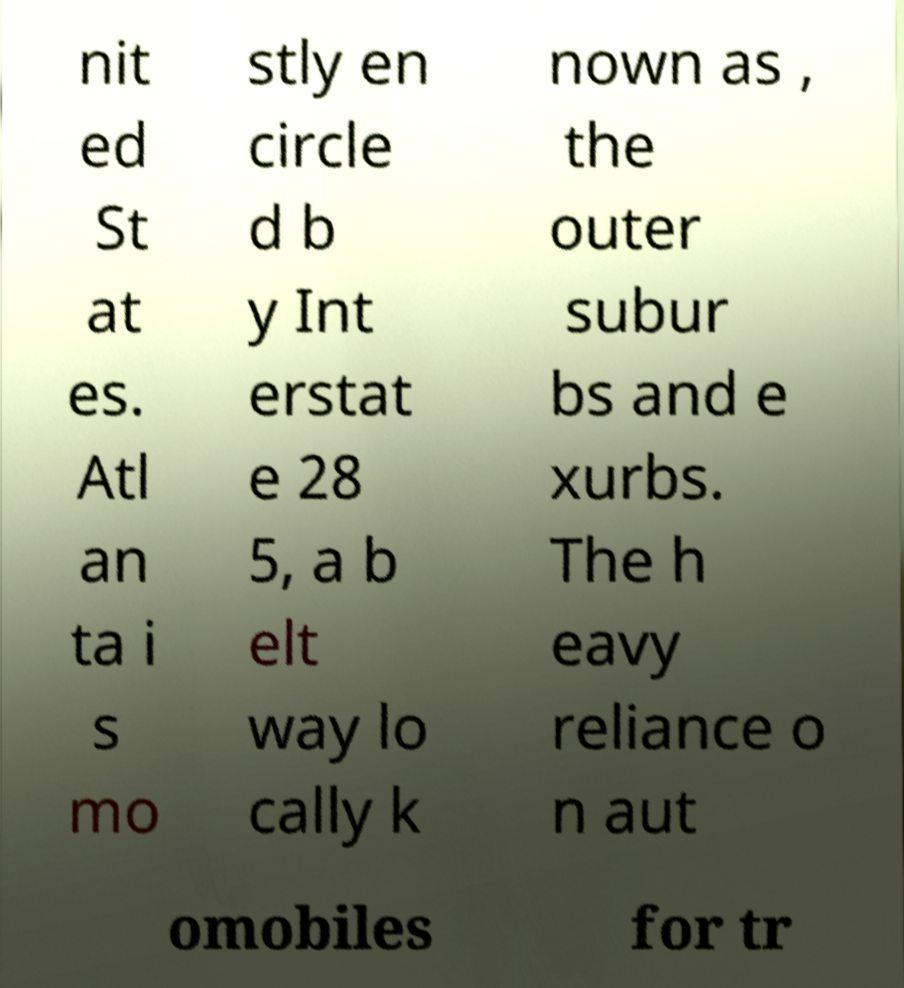Could you assist in decoding the text presented in this image and type it out clearly? nit ed St at es. Atl an ta i s mo stly en circle d b y Int erstat e 28 5, a b elt way lo cally k nown as , the outer subur bs and e xurbs. The h eavy reliance o n aut omobiles for tr 